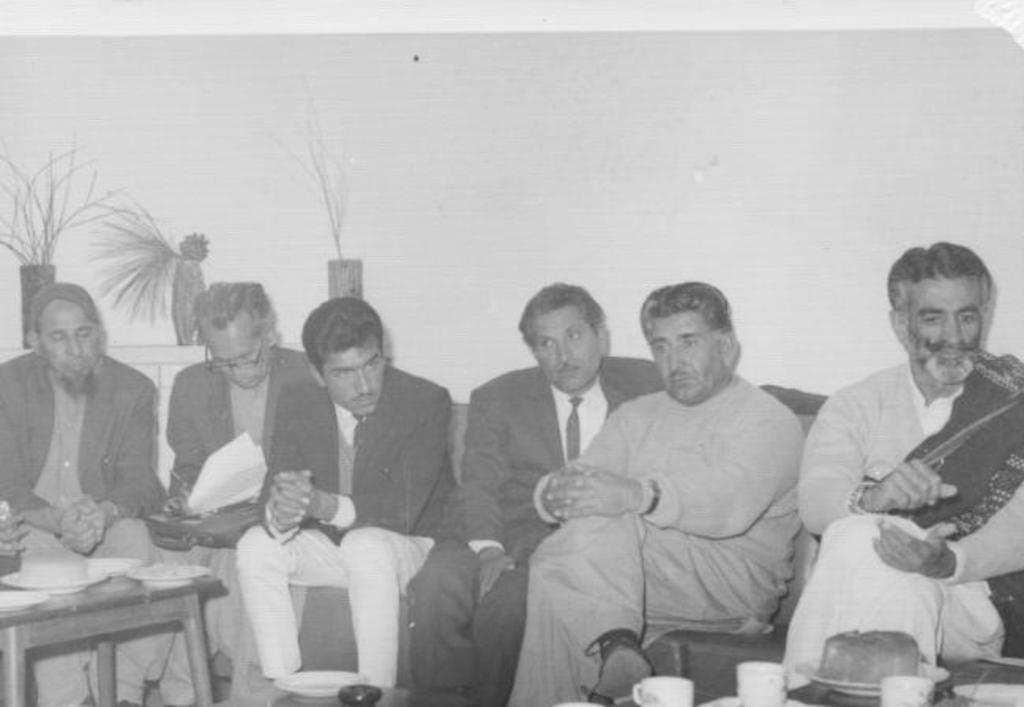Can you describe this image briefly? In this black and white image, we can see a group of people wearing clothes and sitting in front of the wall. There are flower vases on the left side of the image. There is a table in the bottom left of the image. 